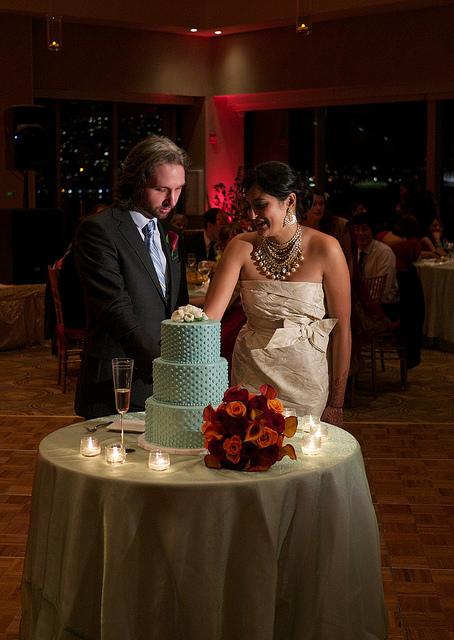Are these people in love?
Short answer required. Yes. What are these people celebrating?
Be succinct. Wedding. What color is the cake?
Give a very brief answer. Blue. 